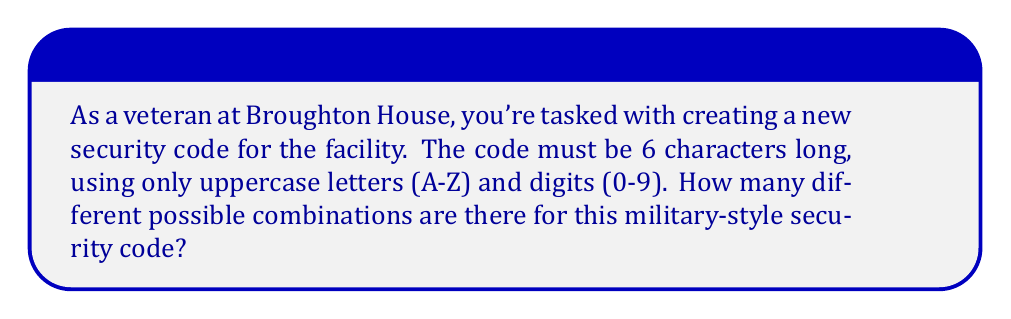Can you answer this question? Let's approach this step-by-step:

1) First, we need to determine how many choices we have for each character position:
   - There are 26 uppercase letters (A-Z)
   - There are 10 digits (0-9)
   - So, for each position, we have 26 + 10 = 36 possible characters

2) Now, we need to use the multiplication principle of counting:
   - We have 6 positions to fill
   - For each position, we have 36 choices
   - The total number of combinations is therefore $36^6$

3) Let's calculate this:
   $36^6 = 36 \times 36 \times 36 \times 36 \times 36 \times 36 = 2,176,782,336$

Therefore, there are 2,176,782,336 possible combinations for the security code.

This large number of possibilities ensures a high level of security, reminiscent of military-grade encryption systems.
Answer: $36^6 = 2,176,782,336$ 